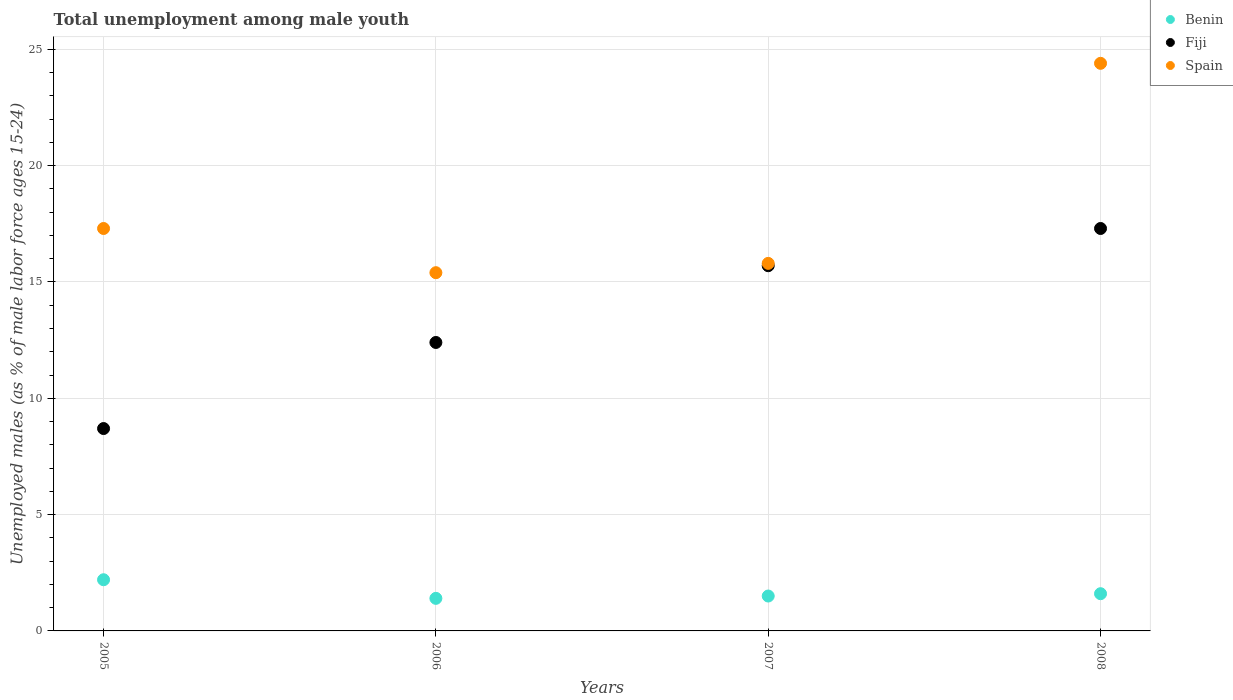Is the number of dotlines equal to the number of legend labels?
Make the answer very short. Yes. What is the percentage of unemployed males in in Spain in 2005?
Offer a very short reply. 17.3. Across all years, what is the maximum percentage of unemployed males in in Benin?
Keep it short and to the point. 2.2. Across all years, what is the minimum percentage of unemployed males in in Fiji?
Your answer should be compact. 8.7. In which year was the percentage of unemployed males in in Spain maximum?
Your answer should be compact. 2008. What is the total percentage of unemployed males in in Benin in the graph?
Your response must be concise. 6.7. What is the difference between the percentage of unemployed males in in Spain in 2007 and that in 2008?
Offer a terse response. -8.6. What is the difference between the percentage of unemployed males in in Fiji in 2008 and the percentage of unemployed males in in Spain in 2007?
Give a very brief answer. 1.5. What is the average percentage of unemployed males in in Benin per year?
Your response must be concise. 1.68. In the year 2008, what is the difference between the percentage of unemployed males in in Fiji and percentage of unemployed males in in Spain?
Your answer should be very brief. -7.1. What is the ratio of the percentage of unemployed males in in Fiji in 2005 to that in 2006?
Offer a very short reply. 0.7. Is the percentage of unemployed males in in Benin in 2005 less than that in 2007?
Provide a succinct answer. No. What is the difference between the highest and the second highest percentage of unemployed males in in Fiji?
Make the answer very short. 1.6. What is the difference between the highest and the lowest percentage of unemployed males in in Spain?
Provide a succinct answer. 9. Is the sum of the percentage of unemployed males in in Fiji in 2006 and 2008 greater than the maximum percentage of unemployed males in in Spain across all years?
Your answer should be compact. Yes. Is it the case that in every year, the sum of the percentage of unemployed males in in Fiji and percentage of unemployed males in in Spain  is greater than the percentage of unemployed males in in Benin?
Make the answer very short. Yes. How many dotlines are there?
Offer a very short reply. 3. How many years are there in the graph?
Keep it short and to the point. 4. What is the difference between two consecutive major ticks on the Y-axis?
Keep it short and to the point. 5. Are the values on the major ticks of Y-axis written in scientific E-notation?
Give a very brief answer. No. Does the graph contain any zero values?
Your answer should be compact. No. What is the title of the graph?
Ensure brevity in your answer.  Total unemployment among male youth. What is the label or title of the X-axis?
Give a very brief answer. Years. What is the label or title of the Y-axis?
Your response must be concise. Unemployed males (as % of male labor force ages 15-24). What is the Unemployed males (as % of male labor force ages 15-24) of Benin in 2005?
Keep it short and to the point. 2.2. What is the Unemployed males (as % of male labor force ages 15-24) in Fiji in 2005?
Your response must be concise. 8.7. What is the Unemployed males (as % of male labor force ages 15-24) in Spain in 2005?
Provide a succinct answer. 17.3. What is the Unemployed males (as % of male labor force ages 15-24) in Benin in 2006?
Provide a succinct answer. 1.4. What is the Unemployed males (as % of male labor force ages 15-24) of Fiji in 2006?
Give a very brief answer. 12.4. What is the Unemployed males (as % of male labor force ages 15-24) of Spain in 2006?
Keep it short and to the point. 15.4. What is the Unemployed males (as % of male labor force ages 15-24) in Benin in 2007?
Your response must be concise. 1.5. What is the Unemployed males (as % of male labor force ages 15-24) of Fiji in 2007?
Give a very brief answer. 15.7. What is the Unemployed males (as % of male labor force ages 15-24) in Spain in 2007?
Provide a short and direct response. 15.8. What is the Unemployed males (as % of male labor force ages 15-24) of Benin in 2008?
Your answer should be compact. 1.6. What is the Unemployed males (as % of male labor force ages 15-24) of Fiji in 2008?
Your answer should be very brief. 17.3. What is the Unemployed males (as % of male labor force ages 15-24) of Spain in 2008?
Your answer should be very brief. 24.4. Across all years, what is the maximum Unemployed males (as % of male labor force ages 15-24) of Benin?
Keep it short and to the point. 2.2. Across all years, what is the maximum Unemployed males (as % of male labor force ages 15-24) of Fiji?
Provide a short and direct response. 17.3. Across all years, what is the maximum Unemployed males (as % of male labor force ages 15-24) of Spain?
Your response must be concise. 24.4. Across all years, what is the minimum Unemployed males (as % of male labor force ages 15-24) of Benin?
Offer a very short reply. 1.4. Across all years, what is the minimum Unemployed males (as % of male labor force ages 15-24) in Fiji?
Provide a short and direct response. 8.7. Across all years, what is the minimum Unemployed males (as % of male labor force ages 15-24) in Spain?
Offer a very short reply. 15.4. What is the total Unemployed males (as % of male labor force ages 15-24) in Benin in the graph?
Offer a terse response. 6.7. What is the total Unemployed males (as % of male labor force ages 15-24) in Fiji in the graph?
Give a very brief answer. 54.1. What is the total Unemployed males (as % of male labor force ages 15-24) in Spain in the graph?
Your answer should be very brief. 72.9. What is the difference between the Unemployed males (as % of male labor force ages 15-24) of Fiji in 2005 and that in 2007?
Give a very brief answer. -7. What is the difference between the Unemployed males (as % of male labor force ages 15-24) of Spain in 2005 and that in 2007?
Offer a very short reply. 1.5. What is the difference between the Unemployed males (as % of male labor force ages 15-24) in Fiji in 2005 and that in 2008?
Provide a short and direct response. -8.6. What is the difference between the Unemployed males (as % of male labor force ages 15-24) of Spain in 2005 and that in 2008?
Keep it short and to the point. -7.1. What is the difference between the Unemployed males (as % of male labor force ages 15-24) of Benin in 2006 and that in 2007?
Keep it short and to the point. -0.1. What is the difference between the Unemployed males (as % of male labor force ages 15-24) of Spain in 2006 and that in 2008?
Your response must be concise. -9. What is the difference between the Unemployed males (as % of male labor force ages 15-24) of Spain in 2007 and that in 2008?
Offer a very short reply. -8.6. What is the difference between the Unemployed males (as % of male labor force ages 15-24) of Benin in 2005 and the Unemployed males (as % of male labor force ages 15-24) of Fiji in 2006?
Your response must be concise. -10.2. What is the difference between the Unemployed males (as % of male labor force ages 15-24) in Benin in 2005 and the Unemployed males (as % of male labor force ages 15-24) in Spain in 2006?
Provide a succinct answer. -13.2. What is the difference between the Unemployed males (as % of male labor force ages 15-24) in Fiji in 2005 and the Unemployed males (as % of male labor force ages 15-24) in Spain in 2006?
Your response must be concise. -6.7. What is the difference between the Unemployed males (as % of male labor force ages 15-24) of Fiji in 2005 and the Unemployed males (as % of male labor force ages 15-24) of Spain in 2007?
Provide a succinct answer. -7.1. What is the difference between the Unemployed males (as % of male labor force ages 15-24) of Benin in 2005 and the Unemployed males (as % of male labor force ages 15-24) of Fiji in 2008?
Make the answer very short. -15.1. What is the difference between the Unemployed males (as % of male labor force ages 15-24) of Benin in 2005 and the Unemployed males (as % of male labor force ages 15-24) of Spain in 2008?
Ensure brevity in your answer.  -22.2. What is the difference between the Unemployed males (as % of male labor force ages 15-24) in Fiji in 2005 and the Unemployed males (as % of male labor force ages 15-24) in Spain in 2008?
Your answer should be very brief. -15.7. What is the difference between the Unemployed males (as % of male labor force ages 15-24) in Benin in 2006 and the Unemployed males (as % of male labor force ages 15-24) in Fiji in 2007?
Make the answer very short. -14.3. What is the difference between the Unemployed males (as % of male labor force ages 15-24) in Benin in 2006 and the Unemployed males (as % of male labor force ages 15-24) in Spain in 2007?
Your answer should be very brief. -14.4. What is the difference between the Unemployed males (as % of male labor force ages 15-24) of Benin in 2006 and the Unemployed males (as % of male labor force ages 15-24) of Fiji in 2008?
Ensure brevity in your answer.  -15.9. What is the difference between the Unemployed males (as % of male labor force ages 15-24) in Benin in 2006 and the Unemployed males (as % of male labor force ages 15-24) in Spain in 2008?
Make the answer very short. -23. What is the difference between the Unemployed males (as % of male labor force ages 15-24) in Fiji in 2006 and the Unemployed males (as % of male labor force ages 15-24) in Spain in 2008?
Your answer should be very brief. -12. What is the difference between the Unemployed males (as % of male labor force ages 15-24) in Benin in 2007 and the Unemployed males (as % of male labor force ages 15-24) in Fiji in 2008?
Your answer should be very brief. -15.8. What is the difference between the Unemployed males (as % of male labor force ages 15-24) in Benin in 2007 and the Unemployed males (as % of male labor force ages 15-24) in Spain in 2008?
Your answer should be compact. -22.9. What is the average Unemployed males (as % of male labor force ages 15-24) in Benin per year?
Your answer should be compact. 1.68. What is the average Unemployed males (as % of male labor force ages 15-24) in Fiji per year?
Keep it short and to the point. 13.53. What is the average Unemployed males (as % of male labor force ages 15-24) in Spain per year?
Provide a succinct answer. 18.23. In the year 2005, what is the difference between the Unemployed males (as % of male labor force ages 15-24) of Benin and Unemployed males (as % of male labor force ages 15-24) of Fiji?
Your answer should be compact. -6.5. In the year 2005, what is the difference between the Unemployed males (as % of male labor force ages 15-24) of Benin and Unemployed males (as % of male labor force ages 15-24) of Spain?
Give a very brief answer. -15.1. In the year 2005, what is the difference between the Unemployed males (as % of male labor force ages 15-24) in Fiji and Unemployed males (as % of male labor force ages 15-24) in Spain?
Offer a terse response. -8.6. In the year 2006, what is the difference between the Unemployed males (as % of male labor force ages 15-24) in Benin and Unemployed males (as % of male labor force ages 15-24) in Fiji?
Offer a very short reply. -11. In the year 2006, what is the difference between the Unemployed males (as % of male labor force ages 15-24) in Benin and Unemployed males (as % of male labor force ages 15-24) in Spain?
Provide a short and direct response. -14. In the year 2007, what is the difference between the Unemployed males (as % of male labor force ages 15-24) of Benin and Unemployed males (as % of male labor force ages 15-24) of Fiji?
Make the answer very short. -14.2. In the year 2007, what is the difference between the Unemployed males (as % of male labor force ages 15-24) of Benin and Unemployed males (as % of male labor force ages 15-24) of Spain?
Give a very brief answer. -14.3. In the year 2007, what is the difference between the Unemployed males (as % of male labor force ages 15-24) of Fiji and Unemployed males (as % of male labor force ages 15-24) of Spain?
Offer a very short reply. -0.1. In the year 2008, what is the difference between the Unemployed males (as % of male labor force ages 15-24) of Benin and Unemployed males (as % of male labor force ages 15-24) of Fiji?
Offer a terse response. -15.7. In the year 2008, what is the difference between the Unemployed males (as % of male labor force ages 15-24) in Benin and Unemployed males (as % of male labor force ages 15-24) in Spain?
Give a very brief answer. -22.8. What is the ratio of the Unemployed males (as % of male labor force ages 15-24) of Benin in 2005 to that in 2006?
Provide a short and direct response. 1.57. What is the ratio of the Unemployed males (as % of male labor force ages 15-24) of Fiji in 2005 to that in 2006?
Make the answer very short. 0.7. What is the ratio of the Unemployed males (as % of male labor force ages 15-24) of Spain in 2005 to that in 2006?
Keep it short and to the point. 1.12. What is the ratio of the Unemployed males (as % of male labor force ages 15-24) of Benin in 2005 to that in 2007?
Give a very brief answer. 1.47. What is the ratio of the Unemployed males (as % of male labor force ages 15-24) of Fiji in 2005 to that in 2007?
Keep it short and to the point. 0.55. What is the ratio of the Unemployed males (as % of male labor force ages 15-24) in Spain in 2005 to that in 2007?
Your answer should be compact. 1.09. What is the ratio of the Unemployed males (as % of male labor force ages 15-24) in Benin in 2005 to that in 2008?
Keep it short and to the point. 1.38. What is the ratio of the Unemployed males (as % of male labor force ages 15-24) of Fiji in 2005 to that in 2008?
Make the answer very short. 0.5. What is the ratio of the Unemployed males (as % of male labor force ages 15-24) in Spain in 2005 to that in 2008?
Ensure brevity in your answer.  0.71. What is the ratio of the Unemployed males (as % of male labor force ages 15-24) in Fiji in 2006 to that in 2007?
Provide a short and direct response. 0.79. What is the ratio of the Unemployed males (as % of male labor force ages 15-24) in Spain in 2006 to that in 2007?
Keep it short and to the point. 0.97. What is the ratio of the Unemployed males (as % of male labor force ages 15-24) in Benin in 2006 to that in 2008?
Keep it short and to the point. 0.88. What is the ratio of the Unemployed males (as % of male labor force ages 15-24) in Fiji in 2006 to that in 2008?
Ensure brevity in your answer.  0.72. What is the ratio of the Unemployed males (as % of male labor force ages 15-24) in Spain in 2006 to that in 2008?
Your response must be concise. 0.63. What is the ratio of the Unemployed males (as % of male labor force ages 15-24) of Benin in 2007 to that in 2008?
Your answer should be very brief. 0.94. What is the ratio of the Unemployed males (as % of male labor force ages 15-24) of Fiji in 2007 to that in 2008?
Keep it short and to the point. 0.91. What is the ratio of the Unemployed males (as % of male labor force ages 15-24) in Spain in 2007 to that in 2008?
Provide a short and direct response. 0.65. What is the difference between the highest and the second highest Unemployed males (as % of male labor force ages 15-24) in Fiji?
Make the answer very short. 1.6. 